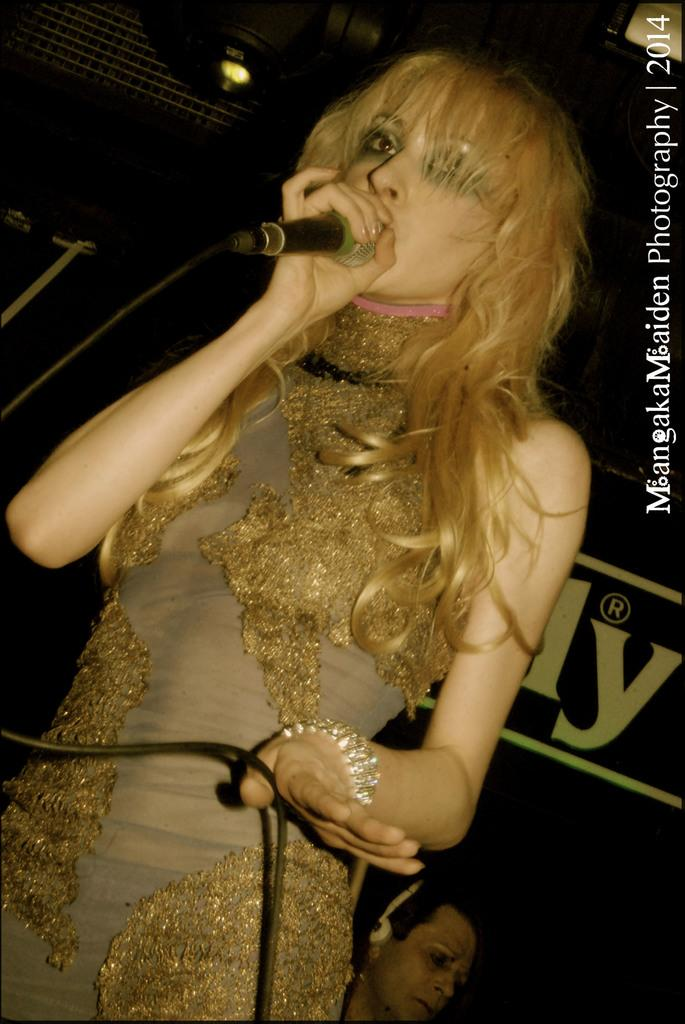Who is the main subject in the image? There is a girl in the image. What is the girl wearing? The girl is wearing a golden dress. Where is the girl positioned in the image? The girl is standing in the front. What is the girl doing in the image? The girl is singing. What can be observed about the background of the image? The background of the image is dark. What type of knowledge can be gained from the girl's whistle in the image? There is no whistle present in the image, so no knowledge can be gained from it. 